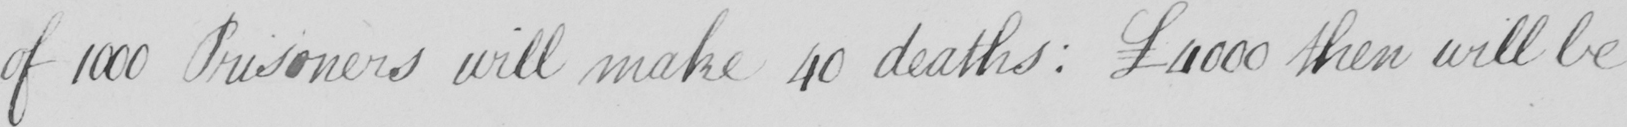Can you read and transcribe this handwriting? of 1000 Prisoners will make 40 deaths :   £4000 then will be 